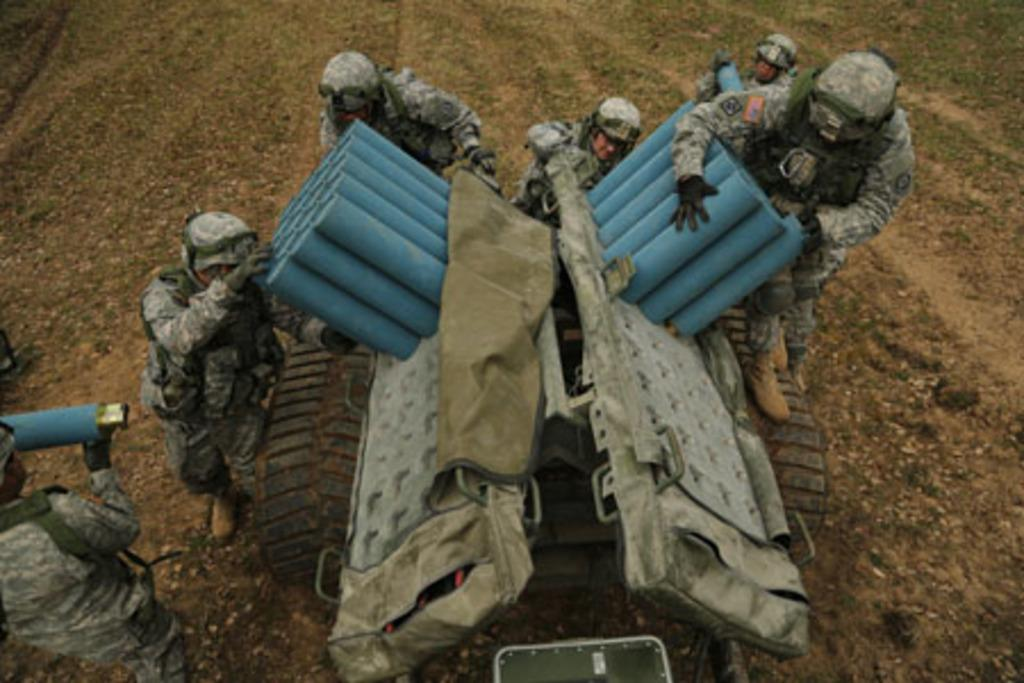What is happening in the image involving a group of people? There is a group of people in the image, and they are standing. What are the people holding in the image? The people are holding launchers in the image. Where are the launchers located on the vehicle? The launchers are on a vehicle in the image. What type of produce is being pushed by the people in the image? There is no produce present in the image, and the people are not pushing anything. 